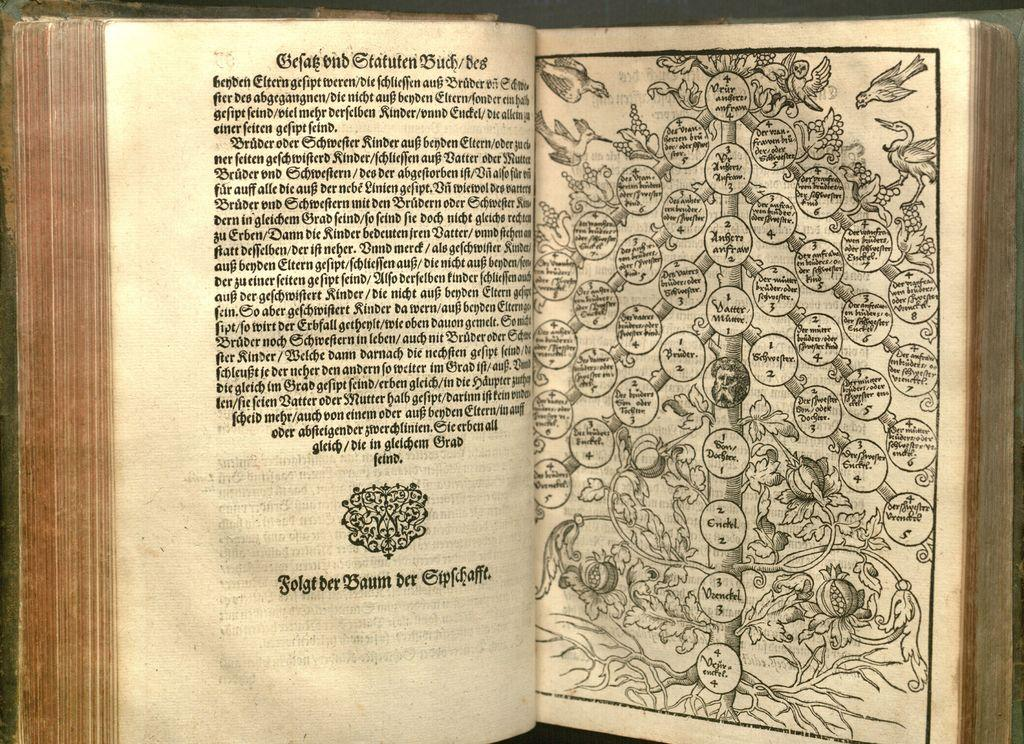Provide a one-sentence caption for the provided image. Open book that has a graph showing bubbles with numbers including number 4. 